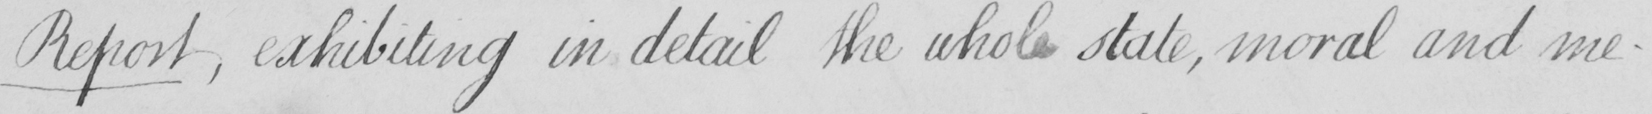Please provide the text content of this handwritten line. Report , exhibiting in detail the whole state , moral and me- 